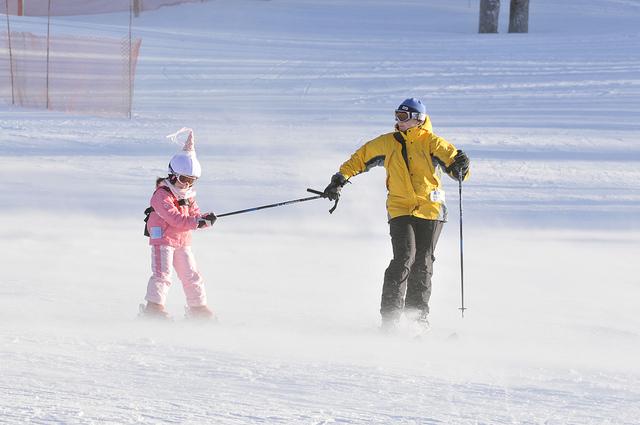Are these people wearing hats?
Give a very brief answer. Yes. Is it springtime?
Keep it brief. No. What style is the yellow and black coat considered to be?
Concise answer only. Ski jacket. Is the climate harsh?
Concise answer only. Yes. 